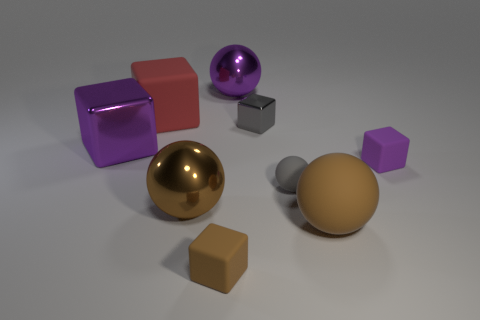There is a matte ball that is the same size as the red object; what color is it?
Your response must be concise. Brown. Are there fewer large matte things that are on the left side of the big red rubber cube than tiny brown blocks in front of the gray matte ball?
Keep it short and to the point. Yes. How many brown balls are behind the large brown object on the right side of the large brown object left of the small brown thing?
Provide a short and direct response. 1. What size is the purple object that is the same shape as the gray rubber thing?
Offer a terse response. Large. Is there any other thing that is the same size as the brown rubber block?
Make the answer very short. Yes. Are there fewer small purple rubber cubes in front of the small metallic object than tiny green cylinders?
Your response must be concise. No. Is the shape of the big red rubber object the same as the large brown matte object?
Provide a short and direct response. No. What color is the other matte thing that is the same shape as the small gray rubber object?
Your response must be concise. Brown. What number of matte blocks have the same color as the large matte sphere?
Ensure brevity in your answer.  1. What number of things are either objects that are in front of the gray cube or large shiny things?
Make the answer very short. 7. 